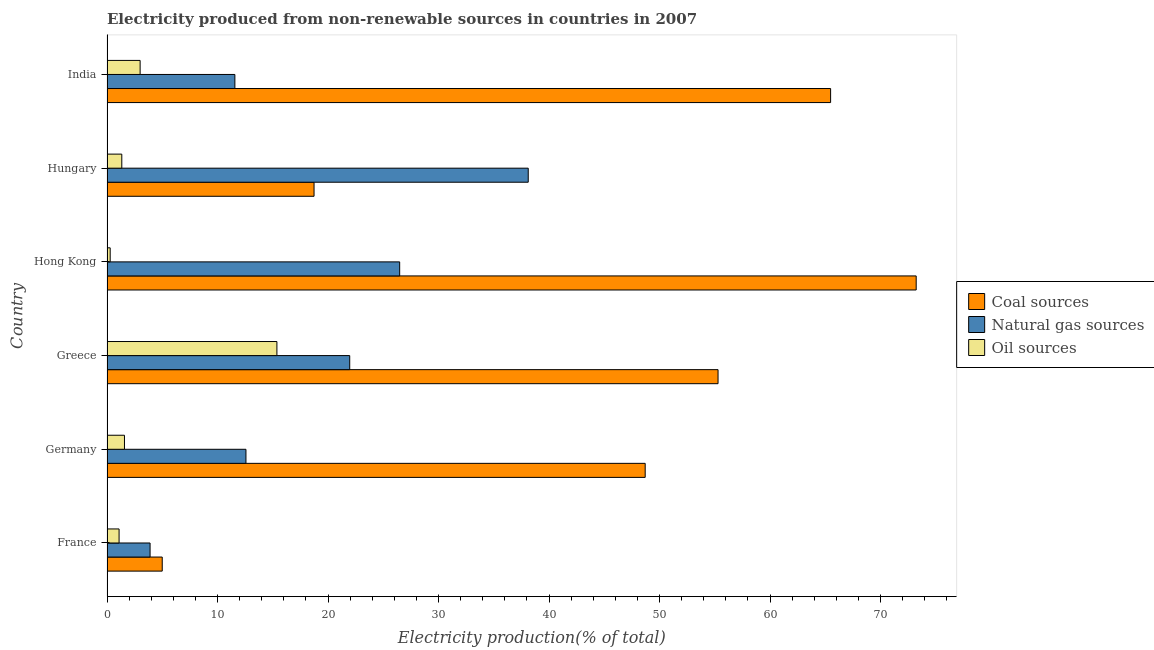How many different coloured bars are there?
Provide a succinct answer. 3. How many bars are there on the 1st tick from the top?
Offer a very short reply. 3. How many bars are there on the 5th tick from the bottom?
Provide a short and direct response. 3. What is the label of the 5th group of bars from the top?
Make the answer very short. Germany. In how many cases, is the number of bars for a given country not equal to the number of legend labels?
Provide a short and direct response. 0. What is the percentage of electricity produced by natural gas in India?
Make the answer very short. 11.57. Across all countries, what is the maximum percentage of electricity produced by coal?
Make the answer very short. 73.23. Across all countries, what is the minimum percentage of electricity produced by oil sources?
Your answer should be compact. 0.29. In which country was the percentage of electricity produced by natural gas maximum?
Provide a succinct answer. Hungary. What is the total percentage of electricity produced by coal in the graph?
Provide a short and direct response. 266.44. What is the difference between the percentage of electricity produced by oil sources in Hong Kong and that in Hungary?
Offer a very short reply. -1.05. What is the difference between the percentage of electricity produced by natural gas in Hong Kong and the percentage of electricity produced by oil sources in Germany?
Ensure brevity in your answer.  24.9. What is the average percentage of electricity produced by natural gas per country?
Offer a terse response. 19.1. What is the difference between the percentage of electricity produced by coal and percentage of electricity produced by oil sources in India?
Make the answer very short. 62.48. In how many countries, is the percentage of electricity produced by natural gas greater than 2 %?
Ensure brevity in your answer.  6. What is the ratio of the percentage of electricity produced by oil sources in Hong Kong to that in Hungary?
Give a very brief answer. 0.21. What is the difference between the highest and the second highest percentage of electricity produced by coal?
Keep it short and to the point. 7.74. What is the difference between the highest and the lowest percentage of electricity produced by coal?
Your answer should be very brief. 68.23. Is the sum of the percentage of electricity produced by oil sources in France and Germany greater than the maximum percentage of electricity produced by coal across all countries?
Ensure brevity in your answer.  No. What does the 2nd bar from the top in Hungary represents?
Make the answer very short. Natural gas sources. What does the 3rd bar from the bottom in Germany represents?
Offer a very short reply. Oil sources. Is it the case that in every country, the sum of the percentage of electricity produced by coal and percentage of electricity produced by natural gas is greater than the percentage of electricity produced by oil sources?
Ensure brevity in your answer.  Yes. How many bars are there?
Provide a short and direct response. 18. Are all the bars in the graph horizontal?
Your response must be concise. Yes. Are the values on the major ticks of X-axis written in scientific E-notation?
Your response must be concise. No. Does the graph contain grids?
Your answer should be compact. No. How many legend labels are there?
Offer a very short reply. 3. What is the title of the graph?
Your response must be concise. Electricity produced from non-renewable sources in countries in 2007. Does "Taxes on international trade" appear as one of the legend labels in the graph?
Provide a short and direct response. No. What is the label or title of the X-axis?
Keep it short and to the point. Electricity production(% of total). What is the Electricity production(% of total) of Coal sources in France?
Give a very brief answer. 5. What is the Electricity production(% of total) of Natural gas sources in France?
Provide a short and direct response. 3.9. What is the Electricity production(% of total) of Oil sources in France?
Ensure brevity in your answer.  1.09. What is the Electricity production(% of total) in Coal sources in Germany?
Provide a short and direct response. 48.7. What is the Electricity production(% of total) in Natural gas sources in Germany?
Offer a terse response. 12.57. What is the Electricity production(% of total) of Oil sources in Germany?
Your response must be concise. 1.58. What is the Electricity production(% of total) in Coal sources in Greece?
Provide a short and direct response. 55.29. What is the Electricity production(% of total) in Natural gas sources in Greece?
Your answer should be very brief. 21.96. What is the Electricity production(% of total) of Oil sources in Greece?
Offer a terse response. 15.38. What is the Electricity production(% of total) in Coal sources in Hong Kong?
Offer a terse response. 73.23. What is the Electricity production(% of total) in Natural gas sources in Hong Kong?
Provide a short and direct response. 26.48. What is the Electricity production(% of total) of Oil sources in Hong Kong?
Your response must be concise. 0.29. What is the Electricity production(% of total) of Coal sources in Hungary?
Your answer should be very brief. 18.74. What is the Electricity production(% of total) of Natural gas sources in Hungary?
Make the answer very short. 38.12. What is the Electricity production(% of total) of Oil sources in Hungary?
Your answer should be compact. 1.34. What is the Electricity production(% of total) in Coal sources in India?
Provide a succinct answer. 65.48. What is the Electricity production(% of total) of Natural gas sources in India?
Provide a short and direct response. 11.57. What is the Electricity production(% of total) in Oil sources in India?
Your answer should be compact. 3. Across all countries, what is the maximum Electricity production(% of total) in Coal sources?
Offer a very short reply. 73.23. Across all countries, what is the maximum Electricity production(% of total) of Natural gas sources?
Your answer should be very brief. 38.12. Across all countries, what is the maximum Electricity production(% of total) in Oil sources?
Your response must be concise. 15.38. Across all countries, what is the minimum Electricity production(% of total) in Coal sources?
Make the answer very short. 5. Across all countries, what is the minimum Electricity production(% of total) of Natural gas sources?
Provide a succinct answer. 3.9. Across all countries, what is the minimum Electricity production(% of total) of Oil sources?
Offer a terse response. 0.29. What is the total Electricity production(% of total) in Coal sources in the graph?
Make the answer very short. 266.44. What is the total Electricity production(% of total) in Natural gas sources in the graph?
Offer a very short reply. 114.61. What is the total Electricity production(% of total) in Oil sources in the graph?
Make the answer very short. 22.67. What is the difference between the Electricity production(% of total) in Coal sources in France and that in Germany?
Your answer should be very brief. -43.7. What is the difference between the Electricity production(% of total) of Natural gas sources in France and that in Germany?
Give a very brief answer. -8.68. What is the difference between the Electricity production(% of total) in Oil sources in France and that in Germany?
Offer a terse response. -0.49. What is the difference between the Electricity production(% of total) of Coal sources in France and that in Greece?
Your answer should be compact. -50.3. What is the difference between the Electricity production(% of total) of Natural gas sources in France and that in Greece?
Offer a terse response. -18.07. What is the difference between the Electricity production(% of total) of Oil sources in France and that in Greece?
Your response must be concise. -14.28. What is the difference between the Electricity production(% of total) in Coal sources in France and that in Hong Kong?
Your answer should be very brief. -68.23. What is the difference between the Electricity production(% of total) of Natural gas sources in France and that in Hong Kong?
Provide a succinct answer. -22.59. What is the difference between the Electricity production(% of total) in Oil sources in France and that in Hong Kong?
Ensure brevity in your answer.  0.8. What is the difference between the Electricity production(% of total) of Coal sources in France and that in Hungary?
Offer a terse response. -13.74. What is the difference between the Electricity production(% of total) of Natural gas sources in France and that in Hungary?
Give a very brief answer. -34.22. What is the difference between the Electricity production(% of total) in Oil sources in France and that in Hungary?
Provide a short and direct response. -0.25. What is the difference between the Electricity production(% of total) of Coal sources in France and that in India?
Make the answer very short. -60.48. What is the difference between the Electricity production(% of total) of Natural gas sources in France and that in India?
Your answer should be very brief. -7.67. What is the difference between the Electricity production(% of total) of Oil sources in France and that in India?
Your answer should be very brief. -1.91. What is the difference between the Electricity production(% of total) of Coal sources in Germany and that in Greece?
Provide a short and direct response. -6.59. What is the difference between the Electricity production(% of total) of Natural gas sources in Germany and that in Greece?
Ensure brevity in your answer.  -9.39. What is the difference between the Electricity production(% of total) of Oil sources in Germany and that in Greece?
Provide a succinct answer. -13.79. What is the difference between the Electricity production(% of total) in Coal sources in Germany and that in Hong Kong?
Make the answer very short. -24.52. What is the difference between the Electricity production(% of total) in Natural gas sources in Germany and that in Hong Kong?
Your answer should be very brief. -13.91. What is the difference between the Electricity production(% of total) in Oil sources in Germany and that in Hong Kong?
Offer a very short reply. 1.29. What is the difference between the Electricity production(% of total) in Coal sources in Germany and that in Hungary?
Your answer should be very brief. 29.97. What is the difference between the Electricity production(% of total) in Natural gas sources in Germany and that in Hungary?
Provide a short and direct response. -25.54. What is the difference between the Electricity production(% of total) of Oil sources in Germany and that in Hungary?
Offer a very short reply. 0.24. What is the difference between the Electricity production(% of total) in Coal sources in Germany and that in India?
Provide a succinct answer. -16.78. What is the difference between the Electricity production(% of total) in Oil sources in Germany and that in India?
Ensure brevity in your answer.  -1.42. What is the difference between the Electricity production(% of total) of Coal sources in Greece and that in Hong Kong?
Make the answer very short. -17.93. What is the difference between the Electricity production(% of total) in Natural gas sources in Greece and that in Hong Kong?
Ensure brevity in your answer.  -4.52. What is the difference between the Electricity production(% of total) of Oil sources in Greece and that in Hong Kong?
Your response must be concise. 15.09. What is the difference between the Electricity production(% of total) in Coal sources in Greece and that in Hungary?
Your answer should be very brief. 36.56. What is the difference between the Electricity production(% of total) of Natural gas sources in Greece and that in Hungary?
Make the answer very short. -16.15. What is the difference between the Electricity production(% of total) in Oil sources in Greece and that in Hungary?
Your answer should be very brief. 14.04. What is the difference between the Electricity production(% of total) of Coal sources in Greece and that in India?
Provide a short and direct response. -10.19. What is the difference between the Electricity production(% of total) of Natural gas sources in Greece and that in India?
Offer a very short reply. 10.39. What is the difference between the Electricity production(% of total) in Oil sources in Greece and that in India?
Provide a short and direct response. 12.38. What is the difference between the Electricity production(% of total) of Coal sources in Hong Kong and that in Hungary?
Your answer should be very brief. 54.49. What is the difference between the Electricity production(% of total) in Natural gas sources in Hong Kong and that in Hungary?
Provide a succinct answer. -11.63. What is the difference between the Electricity production(% of total) of Oil sources in Hong Kong and that in Hungary?
Ensure brevity in your answer.  -1.05. What is the difference between the Electricity production(% of total) of Coal sources in Hong Kong and that in India?
Make the answer very short. 7.74. What is the difference between the Electricity production(% of total) in Natural gas sources in Hong Kong and that in India?
Provide a succinct answer. 14.91. What is the difference between the Electricity production(% of total) of Oil sources in Hong Kong and that in India?
Keep it short and to the point. -2.71. What is the difference between the Electricity production(% of total) of Coal sources in Hungary and that in India?
Offer a terse response. -46.75. What is the difference between the Electricity production(% of total) of Natural gas sources in Hungary and that in India?
Your answer should be compact. 26.55. What is the difference between the Electricity production(% of total) in Oil sources in Hungary and that in India?
Your answer should be compact. -1.66. What is the difference between the Electricity production(% of total) of Coal sources in France and the Electricity production(% of total) of Natural gas sources in Germany?
Provide a succinct answer. -7.58. What is the difference between the Electricity production(% of total) of Coal sources in France and the Electricity production(% of total) of Oil sources in Germany?
Make the answer very short. 3.42. What is the difference between the Electricity production(% of total) of Natural gas sources in France and the Electricity production(% of total) of Oil sources in Germany?
Your response must be concise. 2.32. What is the difference between the Electricity production(% of total) of Coal sources in France and the Electricity production(% of total) of Natural gas sources in Greece?
Offer a terse response. -16.97. What is the difference between the Electricity production(% of total) of Coal sources in France and the Electricity production(% of total) of Oil sources in Greece?
Your answer should be very brief. -10.38. What is the difference between the Electricity production(% of total) of Natural gas sources in France and the Electricity production(% of total) of Oil sources in Greece?
Your answer should be compact. -11.48. What is the difference between the Electricity production(% of total) of Coal sources in France and the Electricity production(% of total) of Natural gas sources in Hong Kong?
Your answer should be very brief. -21.49. What is the difference between the Electricity production(% of total) in Coal sources in France and the Electricity production(% of total) in Oil sources in Hong Kong?
Your answer should be compact. 4.71. What is the difference between the Electricity production(% of total) in Natural gas sources in France and the Electricity production(% of total) in Oil sources in Hong Kong?
Offer a terse response. 3.61. What is the difference between the Electricity production(% of total) of Coal sources in France and the Electricity production(% of total) of Natural gas sources in Hungary?
Ensure brevity in your answer.  -33.12. What is the difference between the Electricity production(% of total) in Coal sources in France and the Electricity production(% of total) in Oil sources in Hungary?
Make the answer very short. 3.66. What is the difference between the Electricity production(% of total) in Natural gas sources in France and the Electricity production(% of total) in Oil sources in Hungary?
Your answer should be very brief. 2.56. What is the difference between the Electricity production(% of total) in Coal sources in France and the Electricity production(% of total) in Natural gas sources in India?
Provide a succinct answer. -6.57. What is the difference between the Electricity production(% of total) of Coal sources in France and the Electricity production(% of total) of Oil sources in India?
Give a very brief answer. 2. What is the difference between the Electricity production(% of total) in Natural gas sources in France and the Electricity production(% of total) in Oil sources in India?
Ensure brevity in your answer.  0.9. What is the difference between the Electricity production(% of total) in Coal sources in Germany and the Electricity production(% of total) in Natural gas sources in Greece?
Offer a very short reply. 26.74. What is the difference between the Electricity production(% of total) in Coal sources in Germany and the Electricity production(% of total) in Oil sources in Greece?
Make the answer very short. 33.33. What is the difference between the Electricity production(% of total) in Natural gas sources in Germany and the Electricity production(% of total) in Oil sources in Greece?
Your response must be concise. -2.8. What is the difference between the Electricity production(% of total) of Coal sources in Germany and the Electricity production(% of total) of Natural gas sources in Hong Kong?
Ensure brevity in your answer.  22.22. What is the difference between the Electricity production(% of total) of Coal sources in Germany and the Electricity production(% of total) of Oil sources in Hong Kong?
Provide a short and direct response. 48.41. What is the difference between the Electricity production(% of total) in Natural gas sources in Germany and the Electricity production(% of total) in Oil sources in Hong Kong?
Provide a succinct answer. 12.29. What is the difference between the Electricity production(% of total) in Coal sources in Germany and the Electricity production(% of total) in Natural gas sources in Hungary?
Make the answer very short. 10.58. What is the difference between the Electricity production(% of total) in Coal sources in Germany and the Electricity production(% of total) in Oil sources in Hungary?
Your response must be concise. 47.36. What is the difference between the Electricity production(% of total) of Natural gas sources in Germany and the Electricity production(% of total) of Oil sources in Hungary?
Provide a short and direct response. 11.23. What is the difference between the Electricity production(% of total) of Coal sources in Germany and the Electricity production(% of total) of Natural gas sources in India?
Provide a short and direct response. 37.13. What is the difference between the Electricity production(% of total) in Coal sources in Germany and the Electricity production(% of total) in Oil sources in India?
Give a very brief answer. 45.7. What is the difference between the Electricity production(% of total) of Natural gas sources in Germany and the Electricity production(% of total) of Oil sources in India?
Make the answer very short. 9.58. What is the difference between the Electricity production(% of total) in Coal sources in Greece and the Electricity production(% of total) in Natural gas sources in Hong Kong?
Offer a terse response. 28.81. What is the difference between the Electricity production(% of total) in Coal sources in Greece and the Electricity production(% of total) in Oil sources in Hong Kong?
Offer a terse response. 55.01. What is the difference between the Electricity production(% of total) in Natural gas sources in Greece and the Electricity production(% of total) in Oil sources in Hong Kong?
Keep it short and to the point. 21.68. What is the difference between the Electricity production(% of total) in Coal sources in Greece and the Electricity production(% of total) in Natural gas sources in Hungary?
Give a very brief answer. 17.18. What is the difference between the Electricity production(% of total) of Coal sources in Greece and the Electricity production(% of total) of Oil sources in Hungary?
Your response must be concise. 53.96. What is the difference between the Electricity production(% of total) of Natural gas sources in Greece and the Electricity production(% of total) of Oil sources in Hungary?
Provide a succinct answer. 20.63. What is the difference between the Electricity production(% of total) of Coal sources in Greece and the Electricity production(% of total) of Natural gas sources in India?
Your response must be concise. 43.72. What is the difference between the Electricity production(% of total) of Coal sources in Greece and the Electricity production(% of total) of Oil sources in India?
Offer a terse response. 52.3. What is the difference between the Electricity production(% of total) of Natural gas sources in Greece and the Electricity production(% of total) of Oil sources in India?
Provide a short and direct response. 18.97. What is the difference between the Electricity production(% of total) of Coal sources in Hong Kong and the Electricity production(% of total) of Natural gas sources in Hungary?
Make the answer very short. 35.11. What is the difference between the Electricity production(% of total) of Coal sources in Hong Kong and the Electricity production(% of total) of Oil sources in Hungary?
Ensure brevity in your answer.  71.89. What is the difference between the Electricity production(% of total) of Natural gas sources in Hong Kong and the Electricity production(% of total) of Oil sources in Hungary?
Keep it short and to the point. 25.14. What is the difference between the Electricity production(% of total) of Coal sources in Hong Kong and the Electricity production(% of total) of Natural gas sources in India?
Keep it short and to the point. 61.65. What is the difference between the Electricity production(% of total) of Coal sources in Hong Kong and the Electricity production(% of total) of Oil sources in India?
Your response must be concise. 70.23. What is the difference between the Electricity production(% of total) in Natural gas sources in Hong Kong and the Electricity production(% of total) in Oil sources in India?
Offer a terse response. 23.49. What is the difference between the Electricity production(% of total) of Coal sources in Hungary and the Electricity production(% of total) of Natural gas sources in India?
Your response must be concise. 7.16. What is the difference between the Electricity production(% of total) in Coal sources in Hungary and the Electricity production(% of total) in Oil sources in India?
Give a very brief answer. 15.74. What is the difference between the Electricity production(% of total) of Natural gas sources in Hungary and the Electricity production(% of total) of Oil sources in India?
Offer a very short reply. 35.12. What is the average Electricity production(% of total) in Coal sources per country?
Offer a very short reply. 44.41. What is the average Electricity production(% of total) in Natural gas sources per country?
Your answer should be compact. 19.1. What is the average Electricity production(% of total) in Oil sources per country?
Ensure brevity in your answer.  3.78. What is the difference between the Electricity production(% of total) in Coal sources and Electricity production(% of total) in Natural gas sources in France?
Your answer should be very brief. 1.1. What is the difference between the Electricity production(% of total) of Coal sources and Electricity production(% of total) of Oil sources in France?
Provide a short and direct response. 3.91. What is the difference between the Electricity production(% of total) of Natural gas sources and Electricity production(% of total) of Oil sources in France?
Your answer should be very brief. 2.81. What is the difference between the Electricity production(% of total) in Coal sources and Electricity production(% of total) in Natural gas sources in Germany?
Give a very brief answer. 36.13. What is the difference between the Electricity production(% of total) of Coal sources and Electricity production(% of total) of Oil sources in Germany?
Ensure brevity in your answer.  47.12. What is the difference between the Electricity production(% of total) in Natural gas sources and Electricity production(% of total) in Oil sources in Germany?
Your response must be concise. 10.99. What is the difference between the Electricity production(% of total) in Coal sources and Electricity production(% of total) in Natural gas sources in Greece?
Your answer should be very brief. 33.33. What is the difference between the Electricity production(% of total) of Coal sources and Electricity production(% of total) of Oil sources in Greece?
Your response must be concise. 39.92. What is the difference between the Electricity production(% of total) in Natural gas sources and Electricity production(% of total) in Oil sources in Greece?
Your response must be concise. 6.59. What is the difference between the Electricity production(% of total) in Coal sources and Electricity production(% of total) in Natural gas sources in Hong Kong?
Your answer should be very brief. 46.74. What is the difference between the Electricity production(% of total) of Coal sources and Electricity production(% of total) of Oil sources in Hong Kong?
Offer a very short reply. 72.94. What is the difference between the Electricity production(% of total) in Natural gas sources and Electricity production(% of total) in Oil sources in Hong Kong?
Keep it short and to the point. 26.2. What is the difference between the Electricity production(% of total) in Coal sources and Electricity production(% of total) in Natural gas sources in Hungary?
Your response must be concise. -19.38. What is the difference between the Electricity production(% of total) in Coal sources and Electricity production(% of total) in Oil sources in Hungary?
Your answer should be compact. 17.4. What is the difference between the Electricity production(% of total) in Natural gas sources and Electricity production(% of total) in Oil sources in Hungary?
Offer a terse response. 36.78. What is the difference between the Electricity production(% of total) of Coal sources and Electricity production(% of total) of Natural gas sources in India?
Offer a terse response. 53.91. What is the difference between the Electricity production(% of total) of Coal sources and Electricity production(% of total) of Oil sources in India?
Keep it short and to the point. 62.48. What is the difference between the Electricity production(% of total) of Natural gas sources and Electricity production(% of total) of Oil sources in India?
Ensure brevity in your answer.  8.57. What is the ratio of the Electricity production(% of total) of Coal sources in France to that in Germany?
Keep it short and to the point. 0.1. What is the ratio of the Electricity production(% of total) in Natural gas sources in France to that in Germany?
Offer a terse response. 0.31. What is the ratio of the Electricity production(% of total) of Oil sources in France to that in Germany?
Your answer should be compact. 0.69. What is the ratio of the Electricity production(% of total) in Coal sources in France to that in Greece?
Make the answer very short. 0.09. What is the ratio of the Electricity production(% of total) of Natural gas sources in France to that in Greece?
Give a very brief answer. 0.18. What is the ratio of the Electricity production(% of total) in Oil sources in France to that in Greece?
Your answer should be compact. 0.07. What is the ratio of the Electricity production(% of total) in Coal sources in France to that in Hong Kong?
Provide a succinct answer. 0.07. What is the ratio of the Electricity production(% of total) in Natural gas sources in France to that in Hong Kong?
Your answer should be very brief. 0.15. What is the ratio of the Electricity production(% of total) in Oil sources in France to that in Hong Kong?
Offer a terse response. 3.8. What is the ratio of the Electricity production(% of total) of Coal sources in France to that in Hungary?
Provide a succinct answer. 0.27. What is the ratio of the Electricity production(% of total) in Natural gas sources in France to that in Hungary?
Your answer should be compact. 0.1. What is the ratio of the Electricity production(% of total) in Oil sources in France to that in Hungary?
Your response must be concise. 0.82. What is the ratio of the Electricity production(% of total) in Coal sources in France to that in India?
Your answer should be compact. 0.08. What is the ratio of the Electricity production(% of total) of Natural gas sources in France to that in India?
Ensure brevity in your answer.  0.34. What is the ratio of the Electricity production(% of total) of Oil sources in France to that in India?
Ensure brevity in your answer.  0.36. What is the ratio of the Electricity production(% of total) in Coal sources in Germany to that in Greece?
Provide a succinct answer. 0.88. What is the ratio of the Electricity production(% of total) in Natural gas sources in Germany to that in Greece?
Give a very brief answer. 0.57. What is the ratio of the Electricity production(% of total) of Oil sources in Germany to that in Greece?
Offer a terse response. 0.1. What is the ratio of the Electricity production(% of total) of Coal sources in Germany to that in Hong Kong?
Provide a short and direct response. 0.67. What is the ratio of the Electricity production(% of total) in Natural gas sources in Germany to that in Hong Kong?
Your response must be concise. 0.47. What is the ratio of the Electricity production(% of total) of Oil sources in Germany to that in Hong Kong?
Keep it short and to the point. 5.5. What is the ratio of the Electricity production(% of total) of Coal sources in Germany to that in Hungary?
Make the answer very short. 2.6. What is the ratio of the Electricity production(% of total) in Natural gas sources in Germany to that in Hungary?
Keep it short and to the point. 0.33. What is the ratio of the Electricity production(% of total) of Oil sources in Germany to that in Hungary?
Provide a succinct answer. 1.18. What is the ratio of the Electricity production(% of total) of Coal sources in Germany to that in India?
Your response must be concise. 0.74. What is the ratio of the Electricity production(% of total) of Natural gas sources in Germany to that in India?
Give a very brief answer. 1.09. What is the ratio of the Electricity production(% of total) in Oil sources in Germany to that in India?
Your answer should be very brief. 0.53. What is the ratio of the Electricity production(% of total) in Coal sources in Greece to that in Hong Kong?
Your answer should be compact. 0.76. What is the ratio of the Electricity production(% of total) of Natural gas sources in Greece to that in Hong Kong?
Give a very brief answer. 0.83. What is the ratio of the Electricity production(% of total) of Oil sources in Greece to that in Hong Kong?
Make the answer very short. 53.47. What is the ratio of the Electricity production(% of total) in Coal sources in Greece to that in Hungary?
Offer a terse response. 2.95. What is the ratio of the Electricity production(% of total) in Natural gas sources in Greece to that in Hungary?
Ensure brevity in your answer.  0.58. What is the ratio of the Electricity production(% of total) in Oil sources in Greece to that in Hungary?
Your answer should be compact. 11.48. What is the ratio of the Electricity production(% of total) in Coal sources in Greece to that in India?
Your answer should be very brief. 0.84. What is the ratio of the Electricity production(% of total) in Natural gas sources in Greece to that in India?
Offer a terse response. 1.9. What is the ratio of the Electricity production(% of total) of Oil sources in Greece to that in India?
Offer a very short reply. 5.13. What is the ratio of the Electricity production(% of total) of Coal sources in Hong Kong to that in Hungary?
Ensure brevity in your answer.  3.91. What is the ratio of the Electricity production(% of total) in Natural gas sources in Hong Kong to that in Hungary?
Your response must be concise. 0.69. What is the ratio of the Electricity production(% of total) in Oil sources in Hong Kong to that in Hungary?
Your answer should be very brief. 0.21. What is the ratio of the Electricity production(% of total) in Coal sources in Hong Kong to that in India?
Ensure brevity in your answer.  1.12. What is the ratio of the Electricity production(% of total) of Natural gas sources in Hong Kong to that in India?
Offer a very short reply. 2.29. What is the ratio of the Electricity production(% of total) in Oil sources in Hong Kong to that in India?
Make the answer very short. 0.1. What is the ratio of the Electricity production(% of total) of Coal sources in Hungary to that in India?
Keep it short and to the point. 0.29. What is the ratio of the Electricity production(% of total) in Natural gas sources in Hungary to that in India?
Offer a terse response. 3.29. What is the ratio of the Electricity production(% of total) in Oil sources in Hungary to that in India?
Your response must be concise. 0.45. What is the difference between the highest and the second highest Electricity production(% of total) of Coal sources?
Your answer should be very brief. 7.74. What is the difference between the highest and the second highest Electricity production(% of total) in Natural gas sources?
Offer a terse response. 11.63. What is the difference between the highest and the second highest Electricity production(% of total) in Oil sources?
Keep it short and to the point. 12.38. What is the difference between the highest and the lowest Electricity production(% of total) in Coal sources?
Make the answer very short. 68.23. What is the difference between the highest and the lowest Electricity production(% of total) in Natural gas sources?
Your answer should be very brief. 34.22. What is the difference between the highest and the lowest Electricity production(% of total) in Oil sources?
Your answer should be very brief. 15.09. 